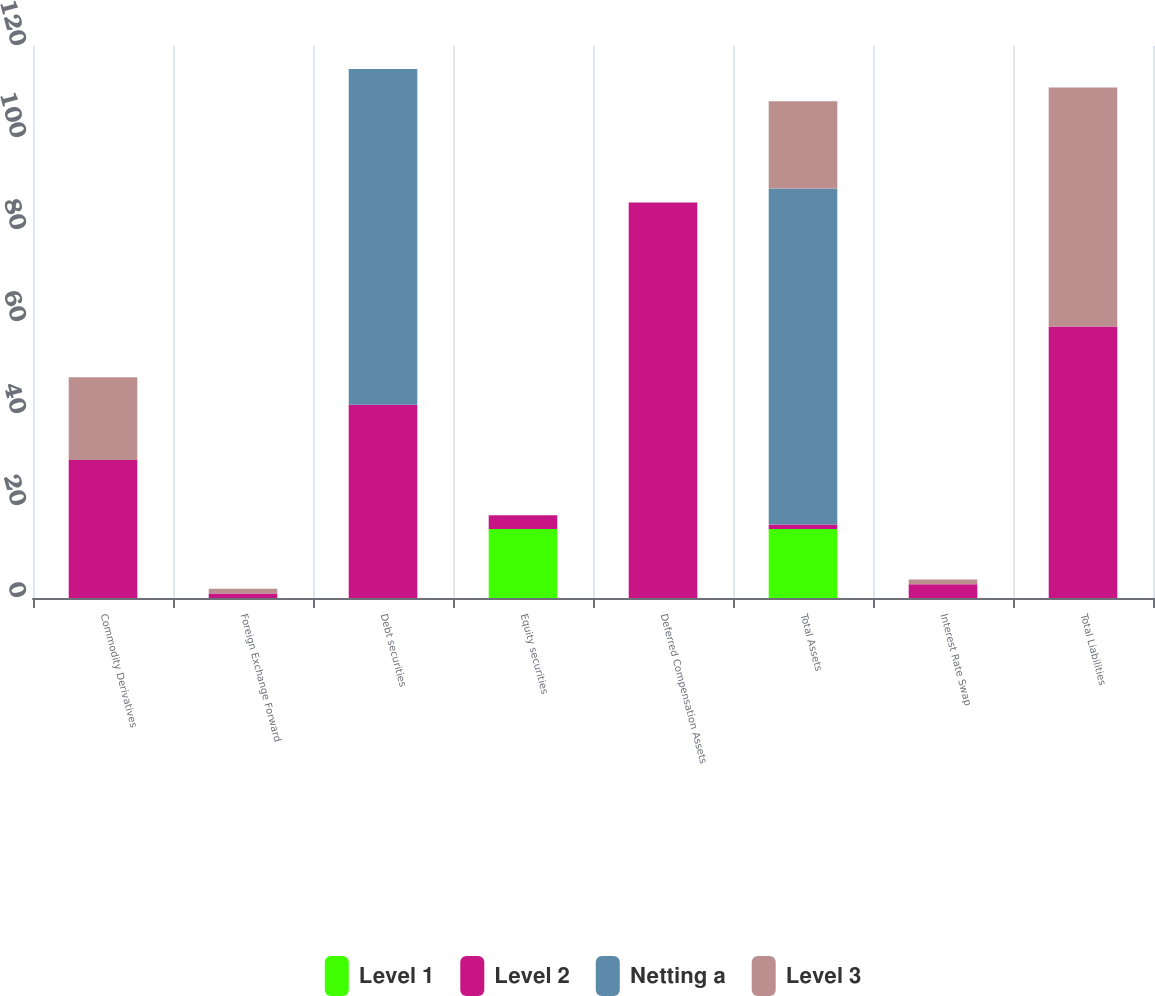<chart> <loc_0><loc_0><loc_500><loc_500><stacked_bar_chart><ecel><fcel>Commodity Derivatives<fcel>Foreign Exchange Forward<fcel>Debt securities<fcel>Equity securities<fcel>Deferred Compensation Assets<fcel>Total Assets<fcel>Interest Rate Swap<fcel>Total Liabilities<nl><fcel>Level 1<fcel>0<fcel>0<fcel>0<fcel>15<fcel>0<fcel>15<fcel>0<fcel>0<nl><fcel>Level 2<fcel>30<fcel>1<fcel>42<fcel>3<fcel>86<fcel>1<fcel>3<fcel>59<nl><fcel>Netting a<fcel>0<fcel>0<fcel>73<fcel>0<fcel>0<fcel>73<fcel>0<fcel>0<nl><fcel>Level 3<fcel>18<fcel>1<fcel>0<fcel>0<fcel>0<fcel>19<fcel>1<fcel>52<nl></chart> 